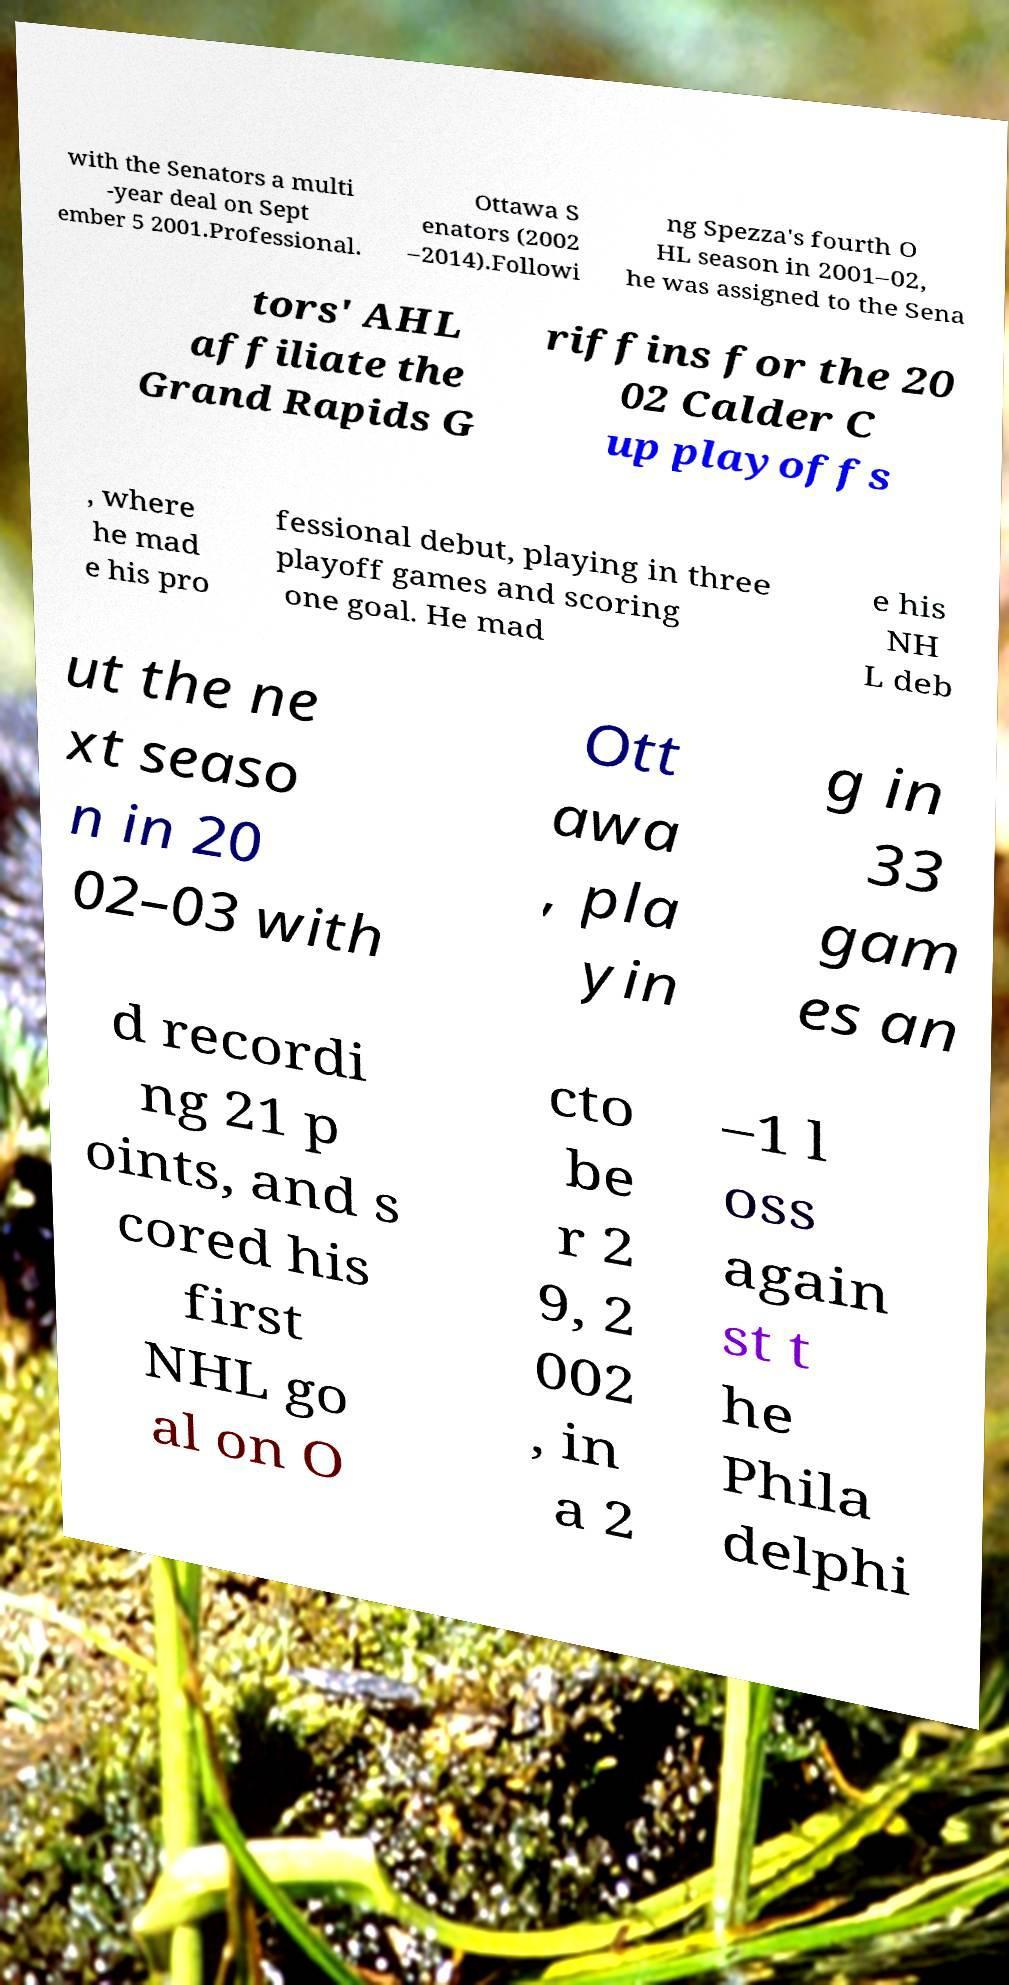I need the written content from this picture converted into text. Can you do that? with the Senators a multi -year deal on Sept ember 5 2001.Professional. Ottawa S enators (2002 –2014).Followi ng Spezza's fourth O HL season in 2001–02, he was assigned to the Sena tors' AHL affiliate the Grand Rapids G riffins for the 20 02 Calder C up playoffs , where he mad e his pro fessional debut, playing in three playoff games and scoring one goal. He mad e his NH L deb ut the ne xt seaso n in 20 02–03 with Ott awa , pla yin g in 33 gam es an d recordi ng 21 p oints, and s cored his first NHL go al on O cto be r 2 9, 2 002 , in a 2 –1 l oss again st t he Phila delphi 